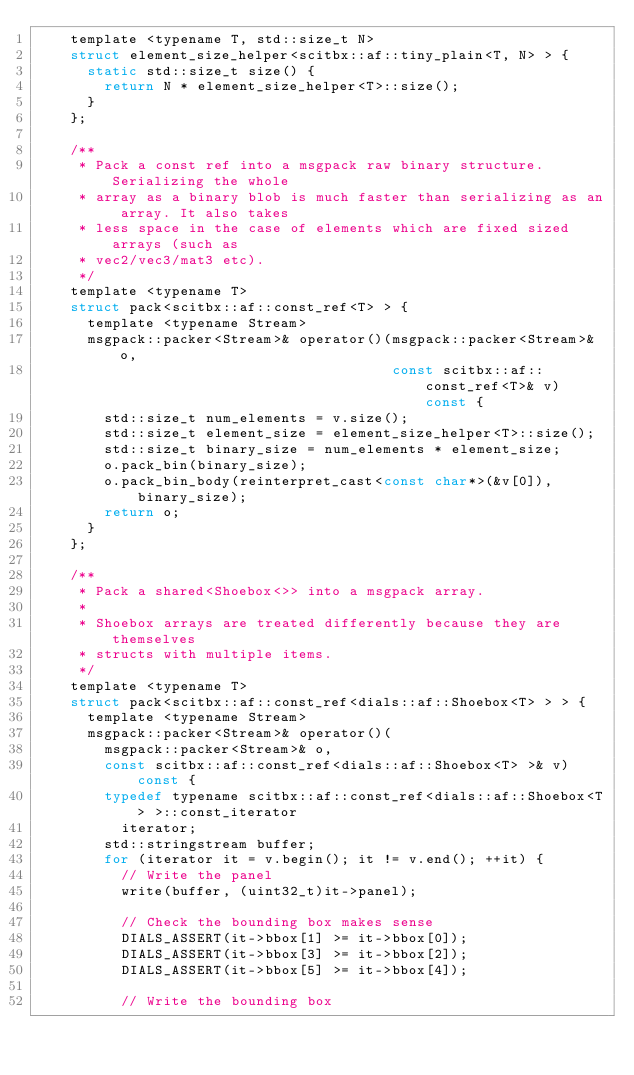Convert code to text. <code><loc_0><loc_0><loc_500><loc_500><_C_>    template <typename T, std::size_t N>
    struct element_size_helper<scitbx::af::tiny_plain<T, N> > {
      static std::size_t size() {
        return N * element_size_helper<T>::size();
      }
    };

    /**
     * Pack a const ref into a msgpack raw binary structure. Serializing the whole
     * array as a binary blob is much faster than serializing as an array. It also takes
     * less space in the case of elements which are fixed sized arrays (such as
     * vec2/vec3/mat3 etc).
     */
    template <typename T>
    struct pack<scitbx::af::const_ref<T> > {
      template <typename Stream>
      msgpack::packer<Stream>& operator()(msgpack::packer<Stream>& o,
                                          const scitbx::af::const_ref<T>& v) const {
        std::size_t num_elements = v.size();
        std::size_t element_size = element_size_helper<T>::size();
        std::size_t binary_size = num_elements * element_size;
        o.pack_bin(binary_size);
        o.pack_bin_body(reinterpret_cast<const char*>(&v[0]), binary_size);
        return o;
      }
    };

    /**
     * Pack a shared<Shoebox<>> into a msgpack array.
     *
     * Shoebox arrays are treated differently because they are themselves
     * structs with multiple items.
     */
    template <typename T>
    struct pack<scitbx::af::const_ref<dials::af::Shoebox<T> > > {
      template <typename Stream>
      msgpack::packer<Stream>& operator()(
        msgpack::packer<Stream>& o,
        const scitbx::af::const_ref<dials::af::Shoebox<T> >& v) const {
        typedef typename scitbx::af::const_ref<dials::af::Shoebox<T> >::const_iterator
          iterator;
        std::stringstream buffer;
        for (iterator it = v.begin(); it != v.end(); ++it) {
          // Write the panel
          write(buffer, (uint32_t)it->panel);

          // Check the bounding box makes sense
          DIALS_ASSERT(it->bbox[1] >= it->bbox[0]);
          DIALS_ASSERT(it->bbox[3] >= it->bbox[2]);
          DIALS_ASSERT(it->bbox[5] >= it->bbox[4]);

          // Write the bounding box</code> 